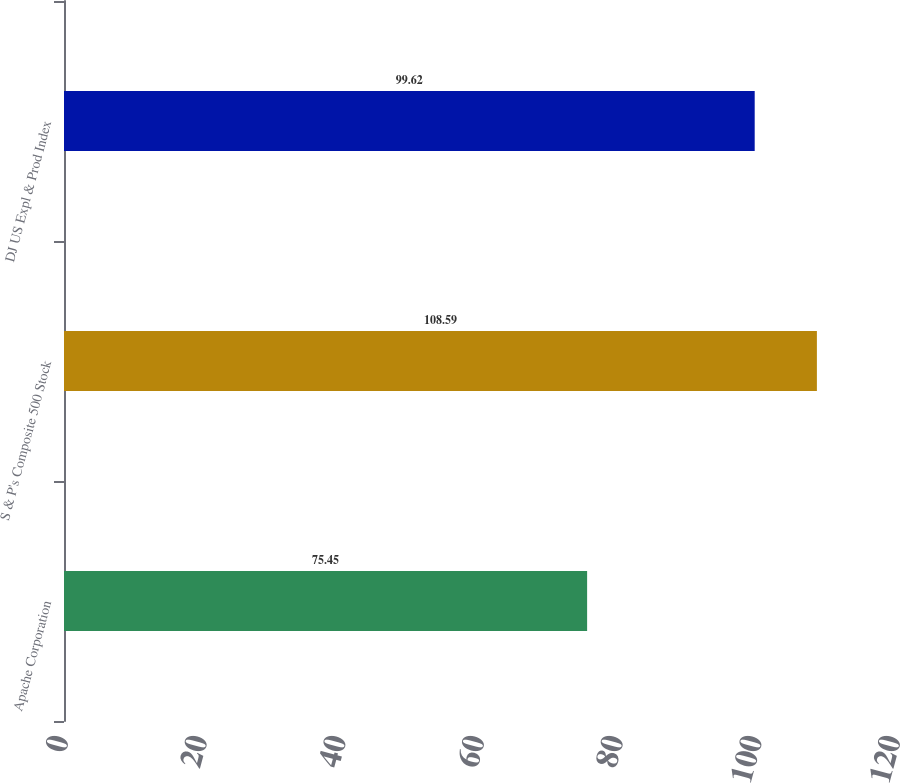<chart> <loc_0><loc_0><loc_500><loc_500><bar_chart><fcel>Apache Corporation<fcel>S & P's Composite 500 Stock<fcel>DJ US Expl & Prod Index<nl><fcel>75.45<fcel>108.59<fcel>99.62<nl></chart> 